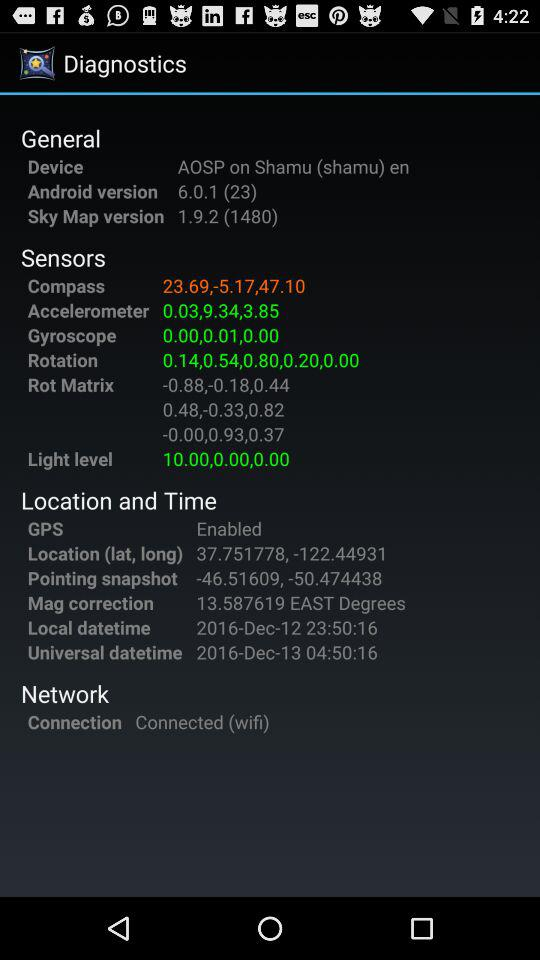What is the name of the device? The name of the device is "AOSP on Shamu (shamu) en". 